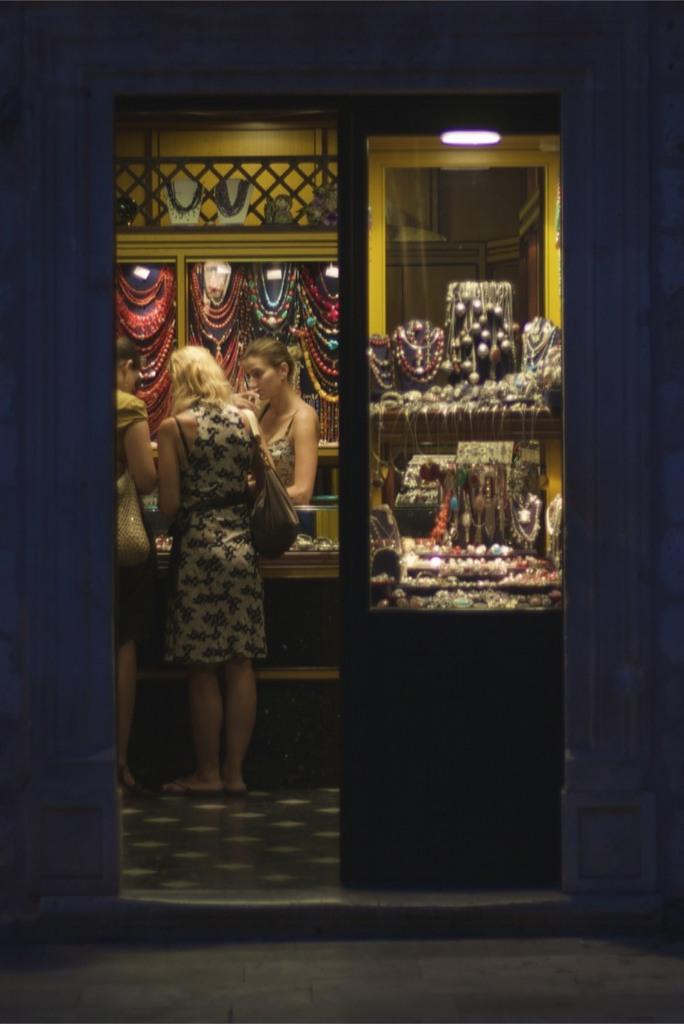What is happening in the image? There is a group of persons standing in the image. What objects can be seen with the persons? There are jewelries in the image. What is the source of light in the image? There is a light hanging on the top of the image. What month is it in the image? The month cannot be determined from the image, as there is no information about the time or date. 